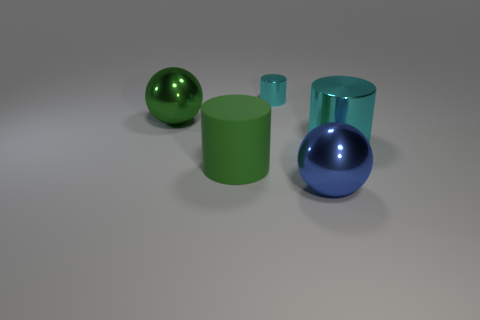Are there any other things that have the same size as the matte cylinder?
Offer a very short reply. Yes. There is a cylinder that is the same material as the tiny thing; what color is it?
Give a very brief answer. Cyan. Does the matte thing have the same size as the metallic sphere that is right of the green rubber cylinder?
Your response must be concise. Yes. What material is the cyan object that is on the right side of the shiny sphere on the right side of the large ball left of the blue thing made of?
Provide a short and direct response. Metal. How many objects are small cyan metallic things or blue objects?
Offer a terse response. 2. There is a big sphere that is behind the big blue thing; does it have the same color as the large shiny object in front of the matte thing?
Offer a very short reply. No. The blue thing that is the same size as the matte cylinder is what shape?
Offer a very short reply. Sphere. What number of objects are either cylinders that are in front of the big cyan metallic object or big cylinders that are right of the matte cylinder?
Offer a terse response. 2. Are there fewer green rubber cylinders than tiny brown matte cylinders?
Your answer should be very brief. No. There is a green cylinder that is the same size as the blue thing; what is it made of?
Keep it short and to the point. Rubber. 